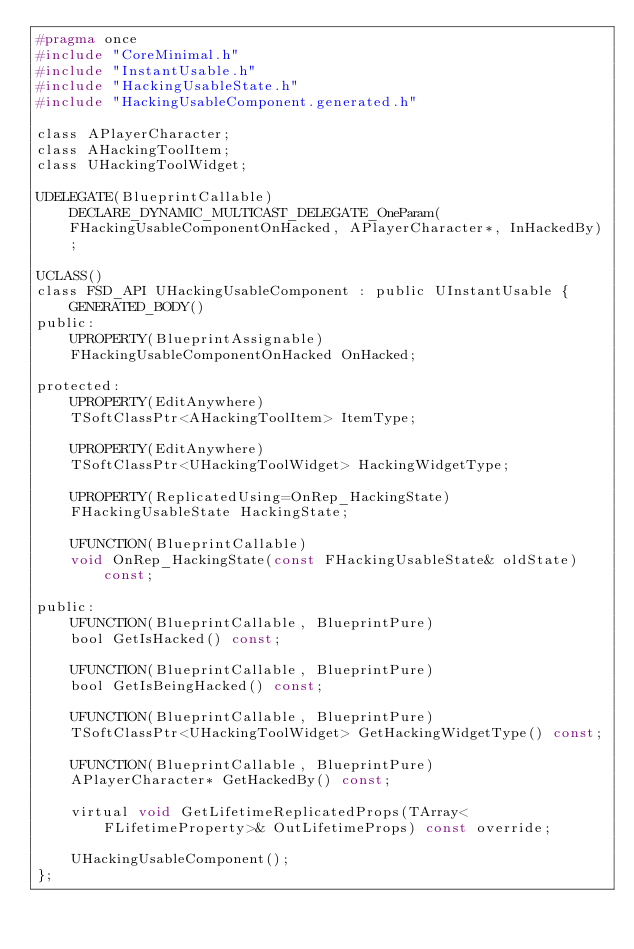<code> <loc_0><loc_0><loc_500><loc_500><_C_>#pragma once
#include "CoreMinimal.h"
#include "InstantUsable.h"
#include "HackingUsableState.h"
#include "HackingUsableComponent.generated.h"

class APlayerCharacter;
class AHackingToolItem;
class UHackingToolWidget;

UDELEGATE(BlueprintCallable) DECLARE_DYNAMIC_MULTICAST_DELEGATE_OneParam(FHackingUsableComponentOnHacked, APlayerCharacter*, InHackedBy);

UCLASS()
class FSD_API UHackingUsableComponent : public UInstantUsable {
    GENERATED_BODY()
public:
    UPROPERTY(BlueprintAssignable)
    FHackingUsableComponentOnHacked OnHacked;
    
protected:
    UPROPERTY(EditAnywhere)
    TSoftClassPtr<AHackingToolItem> ItemType;
    
    UPROPERTY(EditAnywhere)
    TSoftClassPtr<UHackingToolWidget> HackingWidgetType;
    
    UPROPERTY(ReplicatedUsing=OnRep_HackingState)
    FHackingUsableState HackingState;
    
    UFUNCTION(BlueprintCallable)
    void OnRep_HackingState(const FHackingUsableState& oldState) const;
    
public:
    UFUNCTION(BlueprintCallable, BlueprintPure)
    bool GetIsHacked() const;
    
    UFUNCTION(BlueprintCallable, BlueprintPure)
    bool GetIsBeingHacked() const;
    
    UFUNCTION(BlueprintCallable, BlueprintPure)
    TSoftClassPtr<UHackingToolWidget> GetHackingWidgetType() const;
    
    UFUNCTION(BlueprintCallable, BlueprintPure)
    APlayerCharacter* GetHackedBy() const;
    
    virtual void GetLifetimeReplicatedProps(TArray<FLifetimeProperty>& OutLifetimeProps) const override;
    
    UHackingUsableComponent();
};

</code> 